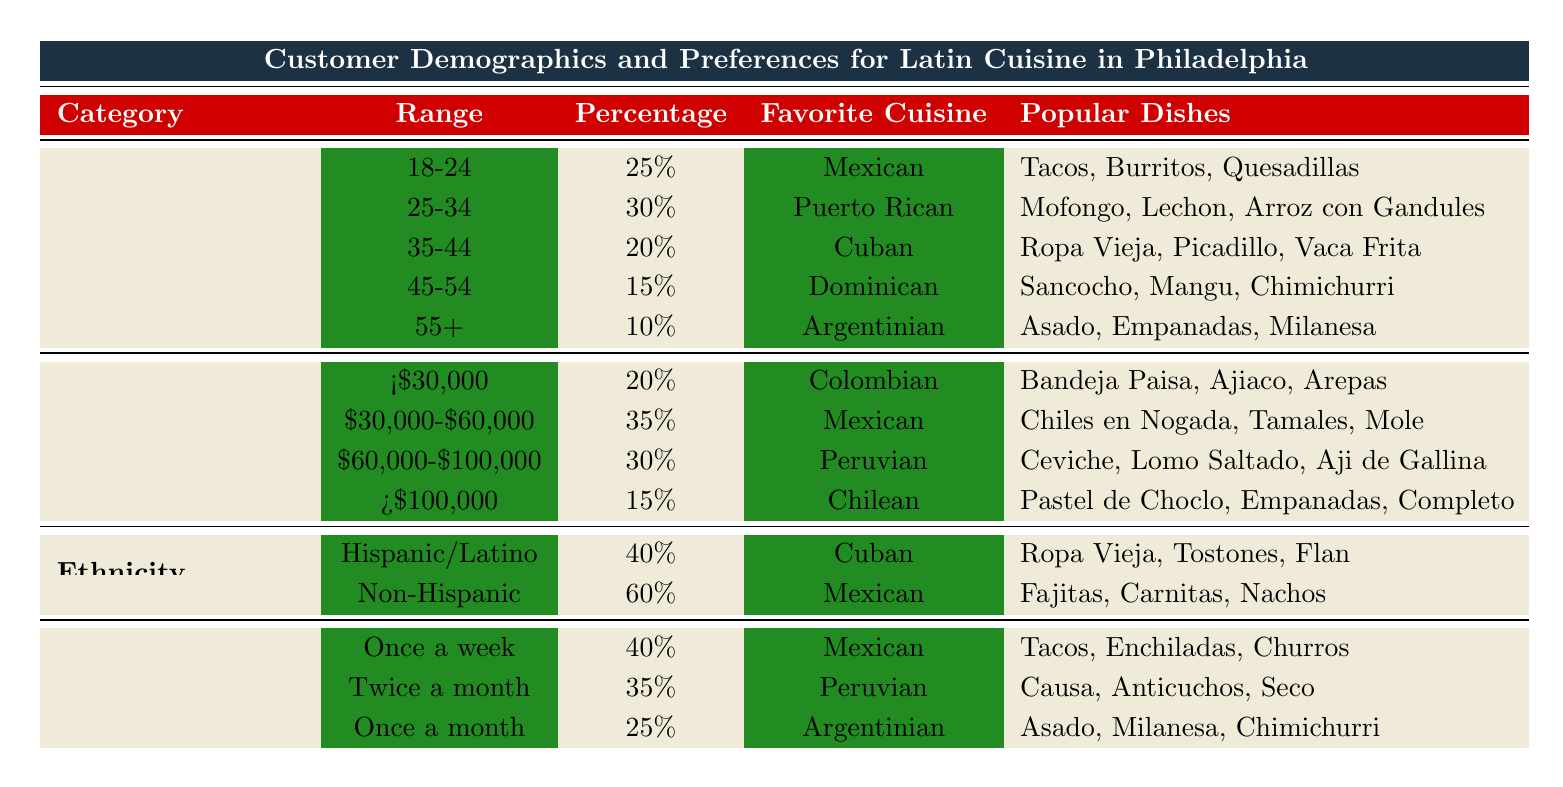What is the most popular cuisine among customers aged 18-24? The table states that the favorite cuisine for the age group 18-24 is Mexican.
Answer: Mexican What percentage of customers prefer Dominican cuisine? The table indicates that 15% of customers aged 45-54 prefer Dominican cuisine.
Answer: 15% How many age groups are represented in the table? The table shows a total of 5 age groups listed under the Age Group category.
Answer: 5 Which cuisine has the highest percentage among Non-Hispanic customers? For the Non-Hispanic ethnicity category, the table shows that the favorite cuisine is Mexican, with 60%.
Answer: Mexican What is the average percentage for the favorite cuisines across all income levels? The percentages are 20, 35, 30, and 15. Adding these gives 100, then dividing by 4 results in an average of 25%.
Answer: 25% Is the favorite cuisine for customers who dine out once a week Mexican? The table confirms that for the frequency of "Once a week," the favorite cuisine is indeed Mexican.
Answer: Yes Which age group has the least percentage of customers? The table notes that the 55+ age group has the least percentage at 10%.
Answer: 10% If you sum the percentages of those who prefer Peruvian cuisine across all categories, what is the total? The percentages of Peruvian preference are 30% (Income Level) and 35% (Dining Frequency). Summing these gives 65%.
Answer: 65% Which cuisine is most popular among customers who visit family-owned restaurants frequently? Customers in the 25-34 age group prefer Puerto Rican cuisine, which is associated with frequent visits to family-owned restaurants.
Answer: Puerto Rican What dining habit is common for customers aged 55 and over? The table indicates that this age group attends food festivals and cultural events, which highlights their dining habit.
Answer: Attend food festivals and cultural events 